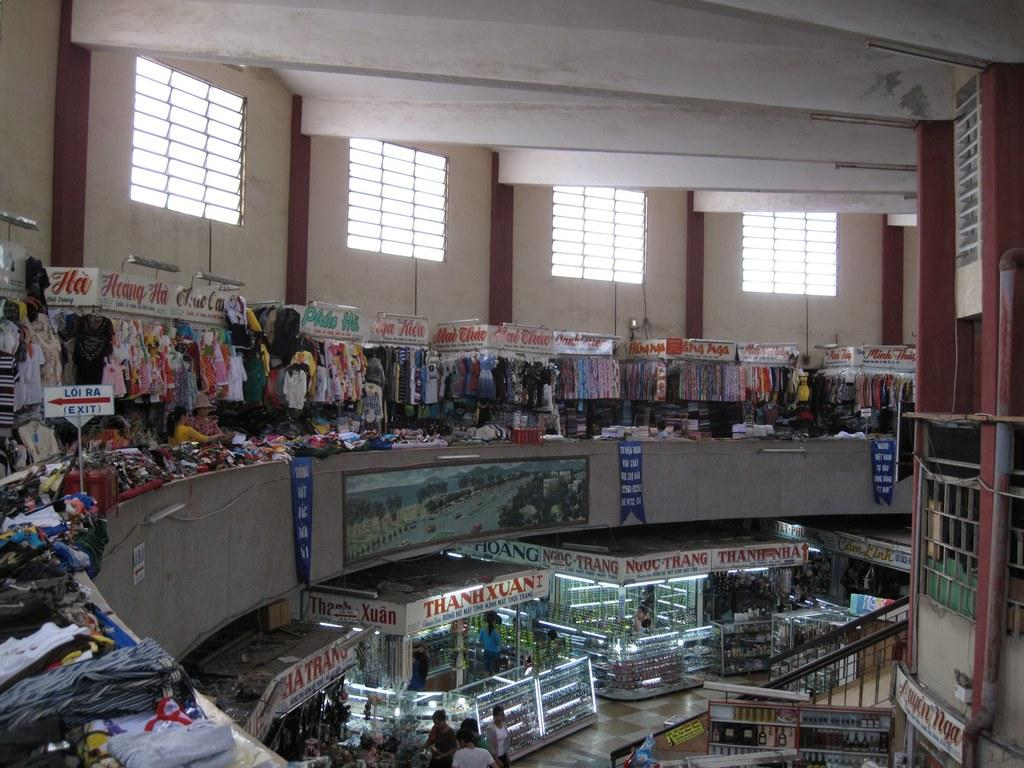<image>
Offer a succinct explanation of the picture presented. a cluttered mall with various shops including Heang Ha and ThanhXuan 